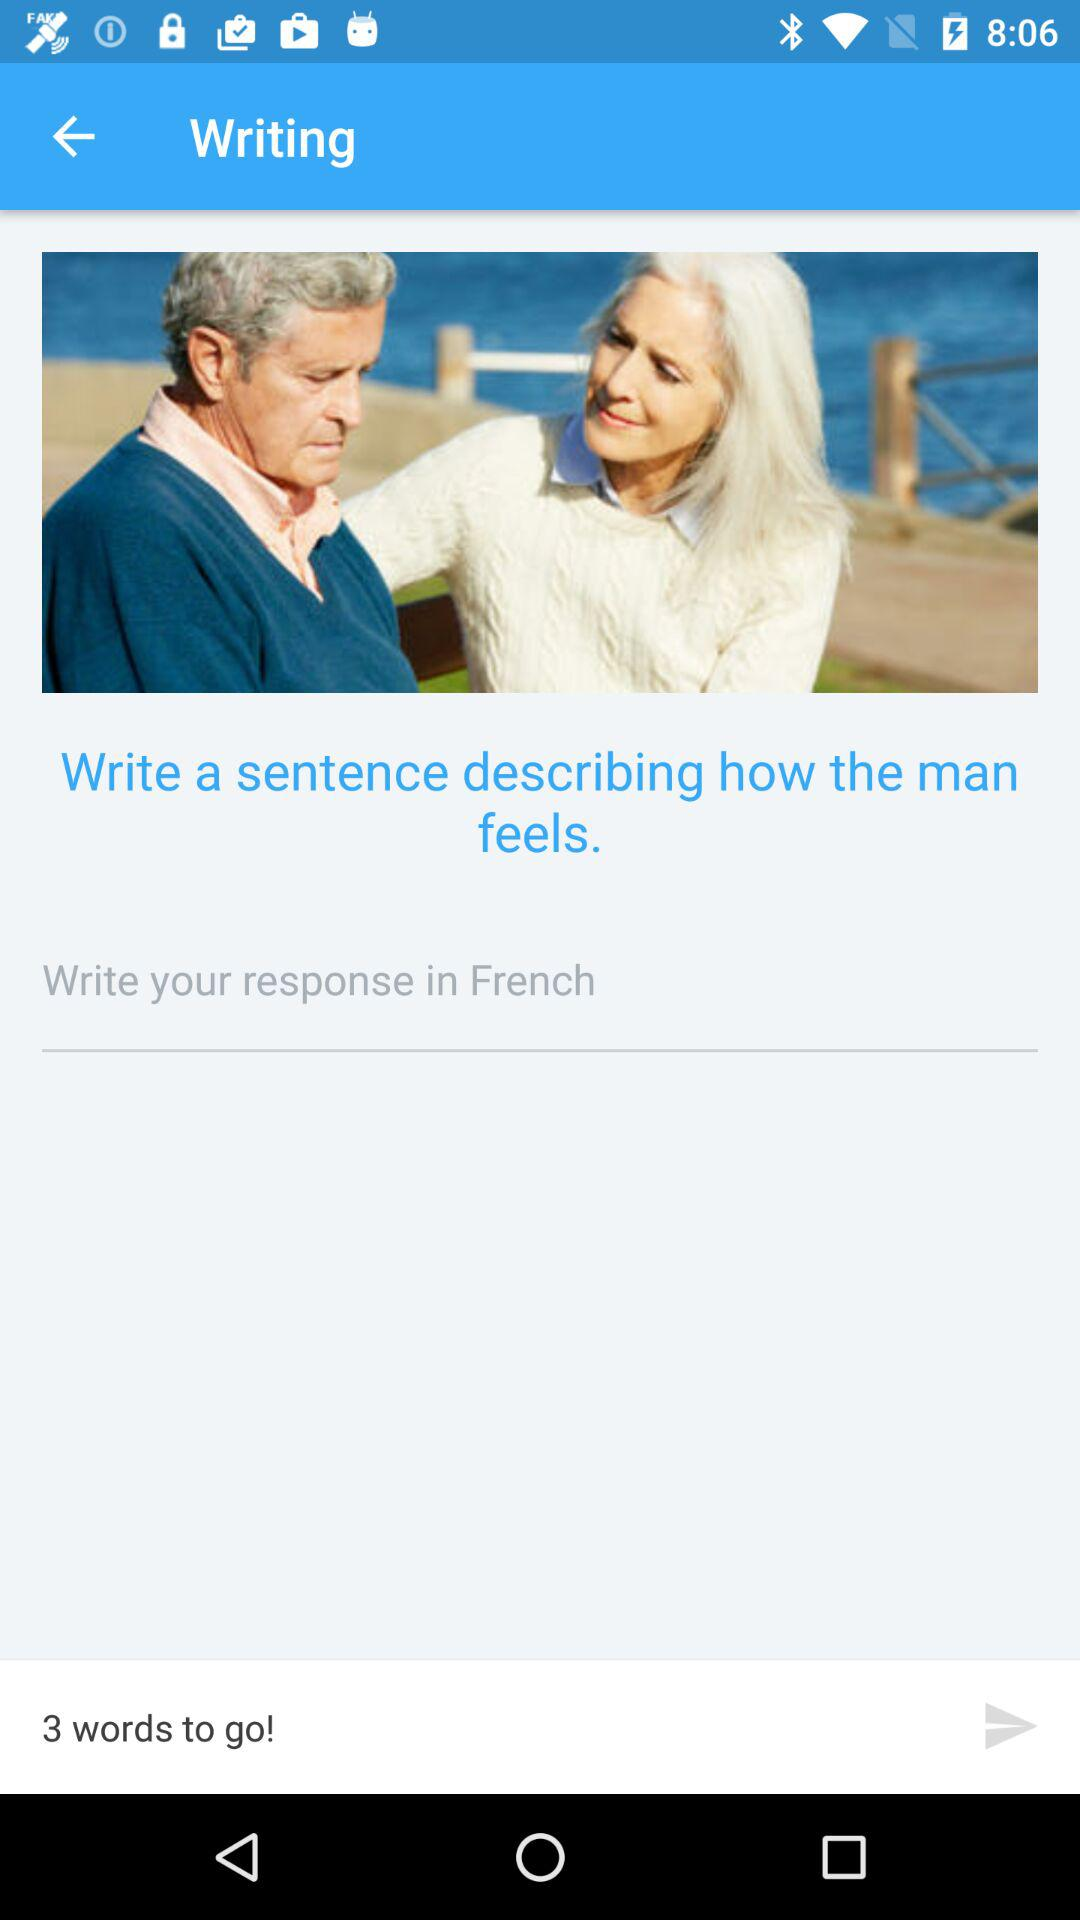How many words are left? There are 3 words left. 